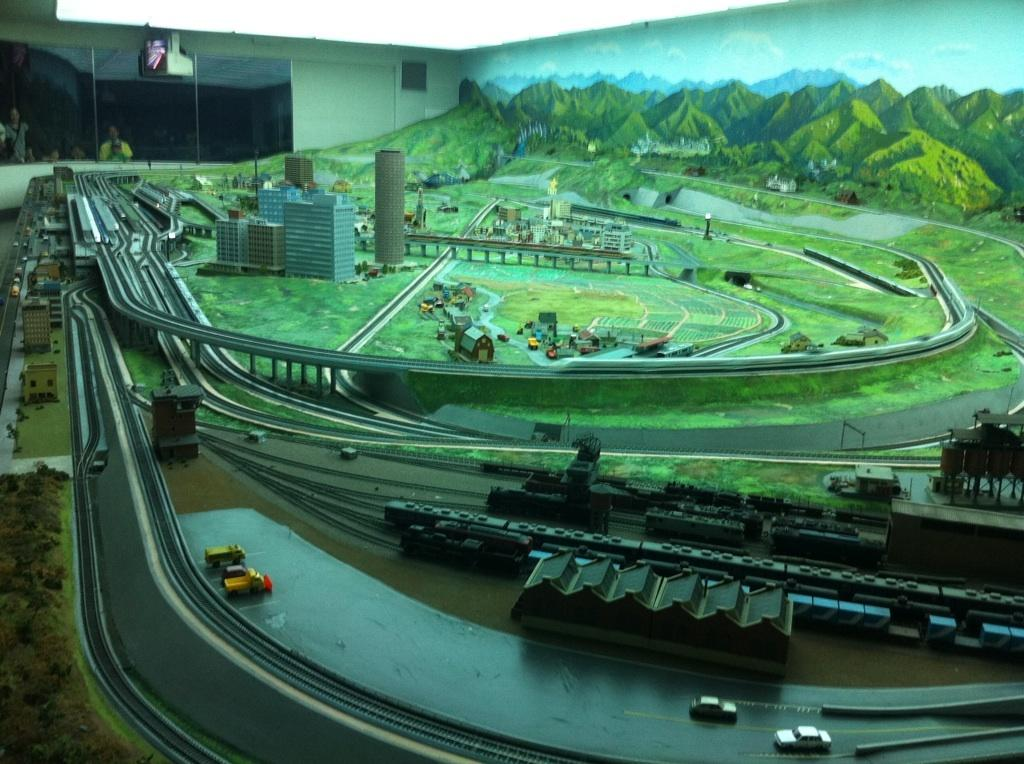What type of vehicle can be seen on the road in the image? There is a vehicle on the road in the image. What other mode of transportation is present in the image? There are trains beside the vehicles in the image. What structure can be seen in the image that allows vehicles to pass over obstacles? There is a bridge in the image. What type of structures can be seen in the image that are used for living or working? There are buildings and houses in the image. What type of natural vegetation can be seen in the image? There are trees in the image. What type of natural landform can be seen in the image? There are mountains in the image. What part of the natural environment is visible in the image? The sky is visible in the image. What type of man-made structure can be seen in the image that serves as a barrier or boundary? There is a wall in the image. What other objects can be seen in the image? There are various objects in the image. Can you see a heart-shaped cherry floating in space in the image? There is no heart-shaped cherry floating in space in the image. 